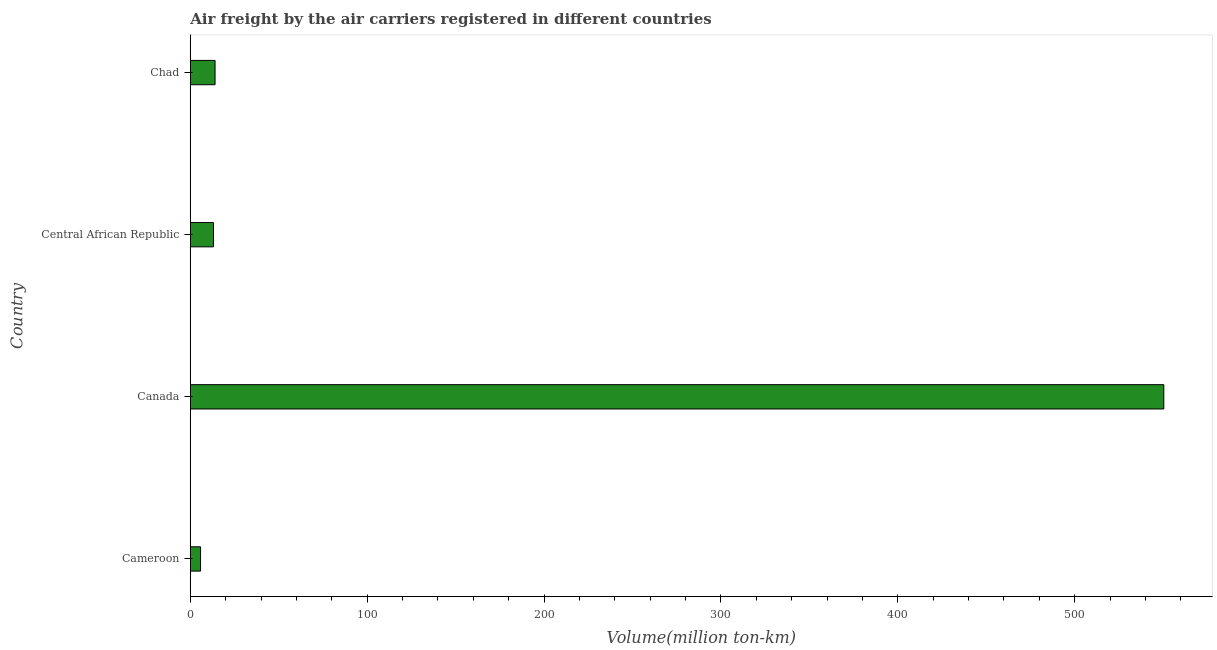Does the graph contain grids?
Your answer should be very brief. No. What is the title of the graph?
Make the answer very short. Air freight by the air carriers registered in different countries. What is the label or title of the X-axis?
Provide a succinct answer. Volume(million ton-km). What is the label or title of the Y-axis?
Make the answer very short. Country. What is the air freight in Central African Republic?
Make the answer very short. 13.1. Across all countries, what is the maximum air freight?
Offer a terse response. 550.4. Across all countries, what is the minimum air freight?
Ensure brevity in your answer.  5.8. In which country was the air freight maximum?
Your response must be concise. Canada. In which country was the air freight minimum?
Offer a very short reply. Cameroon. What is the sum of the air freight?
Ensure brevity in your answer.  583.3. What is the difference between the air freight in Cameroon and Canada?
Make the answer very short. -544.6. What is the average air freight per country?
Offer a very short reply. 145.82. What is the median air freight?
Provide a short and direct response. 13.55. In how many countries, is the air freight greater than 440 million ton-km?
Offer a very short reply. 1. What is the ratio of the air freight in Cameroon to that in Canada?
Offer a terse response. 0.01. What is the difference between the highest and the second highest air freight?
Your response must be concise. 536.4. Is the sum of the air freight in Cameroon and Central African Republic greater than the maximum air freight across all countries?
Your answer should be compact. No. What is the difference between the highest and the lowest air freight?
Offer a terse response. 544.6. How many countries are there in the graph?
Offer a very short reply. 4. What is the difference between two consecutive major ticks on the X-axis?
Make the answer very short. 100. What is the Volume(million ton-km) in Cameroon?
Make the answer very short. 5.8. What is the Volume(million ton-km) in Canada?
Provide a short and direct response. 550.4. What is the Volume(million ton-km) in Central African Republic?
Your response must be concise. 13.1. What is the Volume(million ton-km) in Chad?
Make the answer very short. 14. What is the difference between the Volume(million ton-km) in Cameroon and Canada?
Your answer should be very brief. -544.6. What is the difference between the Volume(million ton-km) in Cameroon and Central African Republic?
Give a very brief answer. -7.3. What is the difference between the Volume(million ton-km) in Cameroon and Chad?
Your response must be concise. -8.2. What is the difference between the Volume(million ton-km) in Canada and Central African Republic?
Offer a terse response. 537.3. What is the difference between the Volume(million ton-km) in Canada and Chad?
Give a very brief answer. 536.4. What is the difference between the Volume(million ton-km) in Central African Republic and Chad?
Offer a terse response. -0.9. What is the ratio of the Volume(million ton-km) in Cameroon to that in Canada?
Ensure brevity in your answer.  0.01. What is the ratio of the Volume(million ton-km) in Cameroon to that in Central African Republic?
Offer a terse response. 0.44. What is the ratio of the Volume(million ton-km) in Cameroon to that in Chad?
Your response must be concise. 0.41. What is the ratio of the Volume(million ton-km) in Canada to that in Central African Republic?
Offer a very short reply. 42.02. What is the ratio of the Volume(million ton-km) in Canada to that in Chad?
Provide a short and direct response. 39.31. What is the ratio of the Volume(million ton-km) in Central African Republic to that in Chad?
Give a very brief answer. 0.94. 